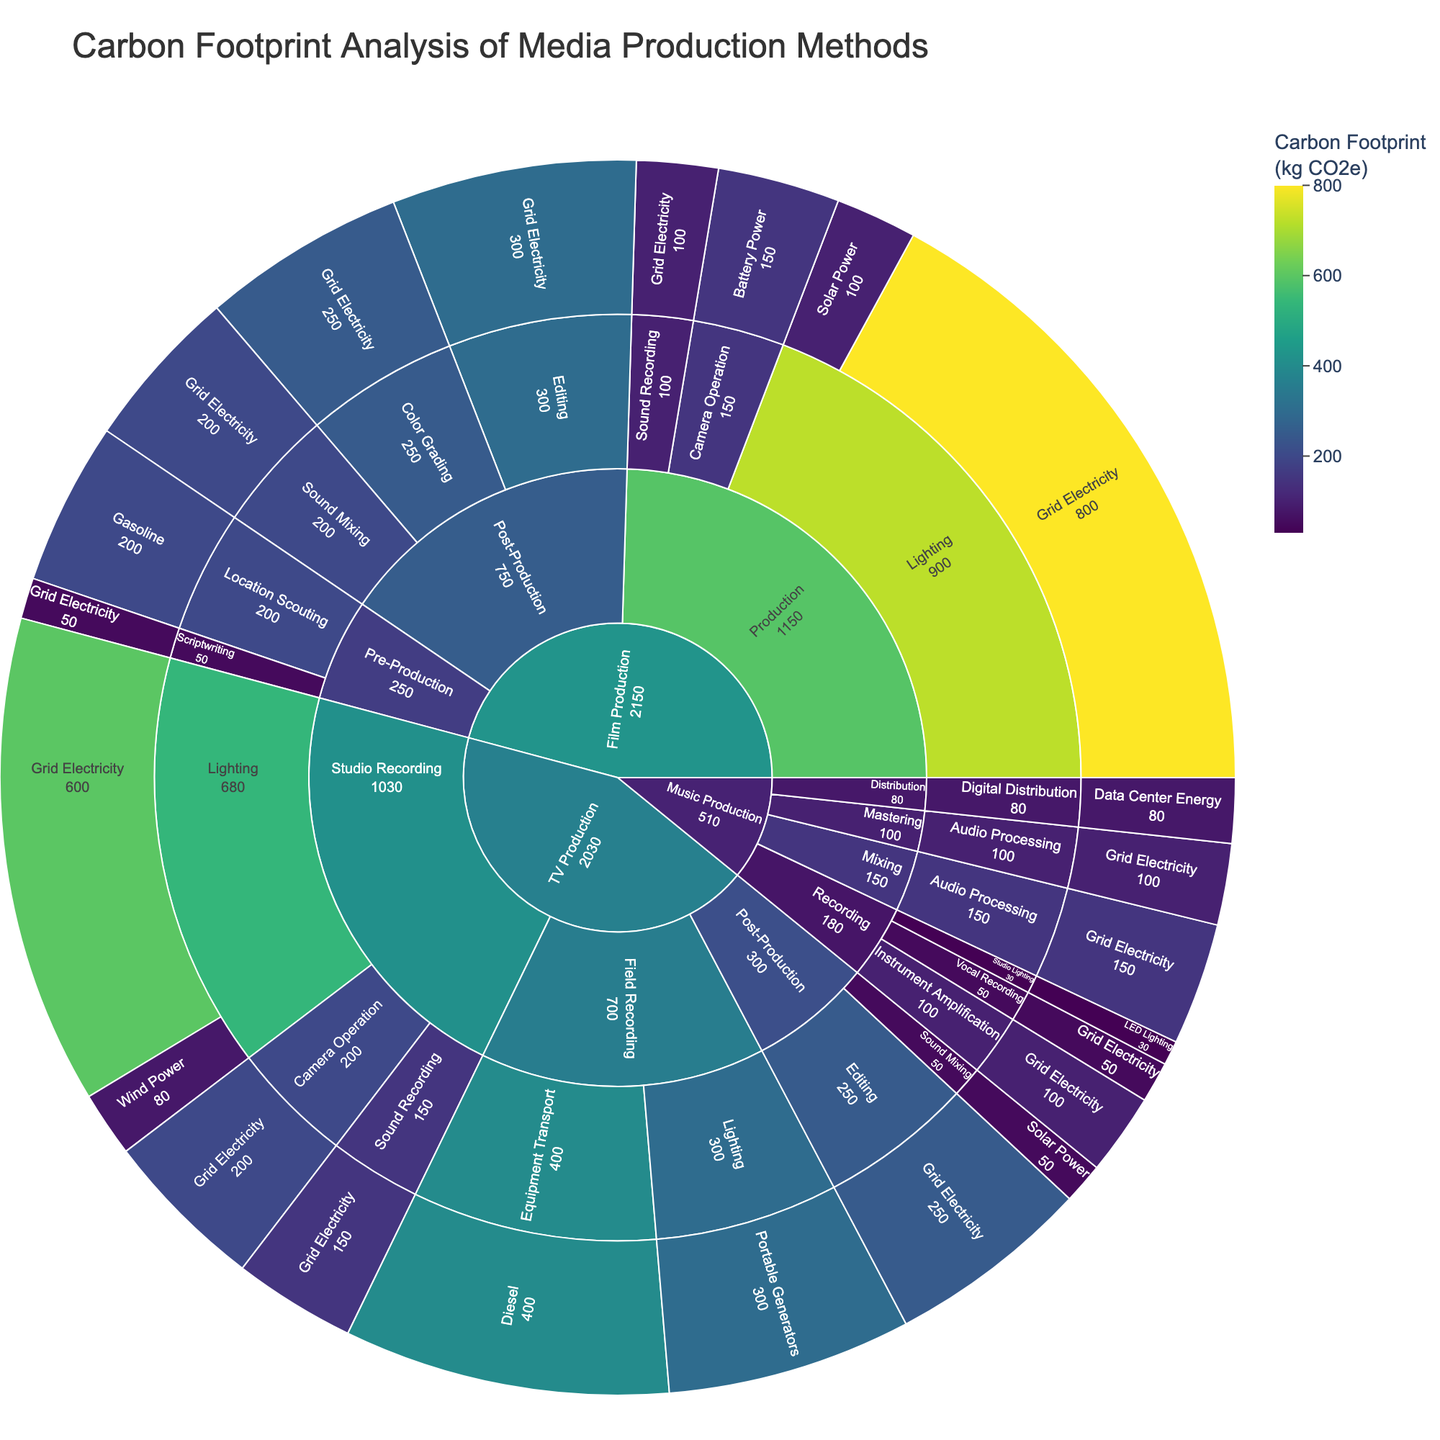What is the category with the largest carbon footprint? Look at the visual size of the sections in the Sunburst Plot. The "Film Production" category has the largest section, indicating it has the largest carbon footprint.
Answer: Film Production How much carbon footprint is produced by the "Pre-Production" stage of "Film Production"? Navigate through the "Film Production" category to the "Pre-Production" subcategory in the Sunburst Plot. Add the carbon footprints of "Scriptwriting" and "Location Scouting": 50 kg CO2e + 200 kg CO2e = 250 kg CO2e.
Answer: 250 kg CO2e Which energy source has the highest carbon footprint in the "TV Production" category? Look at the energy sources within the "TV Production" category in the Sunburst Plot. "Grid Electricity" has the largest section, indicating the highest carbon footprint.
Answer: Grid Electricity What is the total carbon footprint of the "Post-Production" stage in "Film Production"? Navigate to the "Post-Production" subcategory within "Film Production" and sum the carbon footprints of "Editing", "Sound Mixing", and "Color Grading": 300 kg CO2e + 200 kg CO2e + 250 kg CO2e = 750 kg CO2e.
Answer: 750 kg CO2e Compare the carbon footprint of "Lighting" in "Film Production" versus "TV Production". Which is higher? Look at the sections for "Lighting" in both "Film Production" and "TV Production". For "Film Production": 800 kg CO2e + 100 kg CO2e = 900 kg CO2e. For "TV Production": 600 kg CO2e + 80 kg CO2e = 680 kg CO2e. "Film Production" has a higher footprint.
Answer: Film Production Identify the subcategory in "Music Production" that contributes to the smallest carbon footprint. Look at the sections within "Music Production". The "Recording" subcategory has the "Studio Lighting" section with the smallest carbon footprint of 30 kg CO2e.
Answer: Recording What is the total carbon footprint contributed by "Grid Electricity" across all categories? Sum up all instances of "Grid Electricity" across "Film Production", "TV Production", and "Music Production". 50 + 800 + 100 + 100 + 300 + 200 + 250 + 600 + 200 + 150 + 200 + 150 = 3100 kg CO2e.
Answer: 3100 kg CO2e What is the impact of renewable energy sources (Solar Power, Wind Power) in reducing the carbon footprint in the production methods? Identify the instances of Solar Power and Wind Power in the Sunburst Plot and sum up their reduced contributions. Solar Power: 100 (Film Production) + 50 (TV Production) = 150 kg CO2e, Wind Power: 80 kg CO2e (TV Production). Total reduction impact by renewables = 150 + 80 = 230 kg CO2e.
Answer: 230 kg CO2e Does "Battery Power" or "Portable Generators" contribute more to the carbon footprint in the Production phase across all categories? Sum the carbon footprints attributable to "Battery Power" and "Portable Generators". Battery Power: 150 kg CO2e (Film Production), Portable Generators: 300 kg CO2e (TV Production). Portable Generators contribute more.
Answer: Portable Generators 